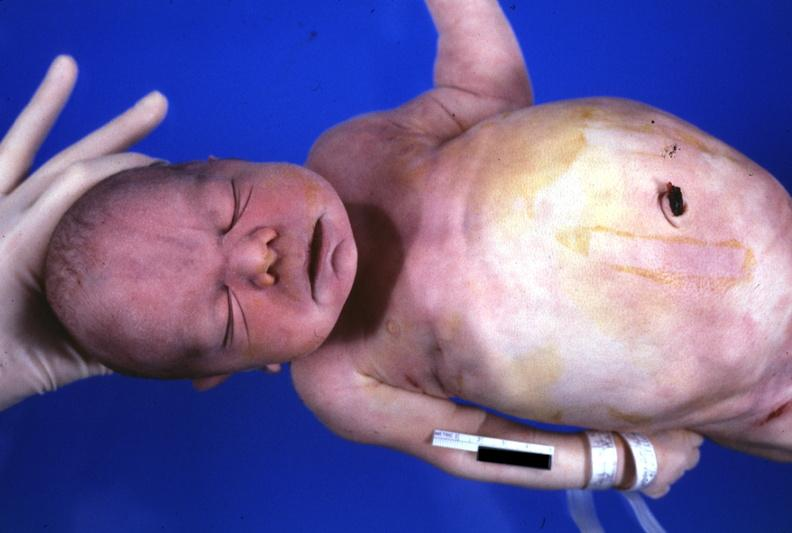s metastatic carcinoma oat cell present?
Answer the question using a single word or phrase. No 